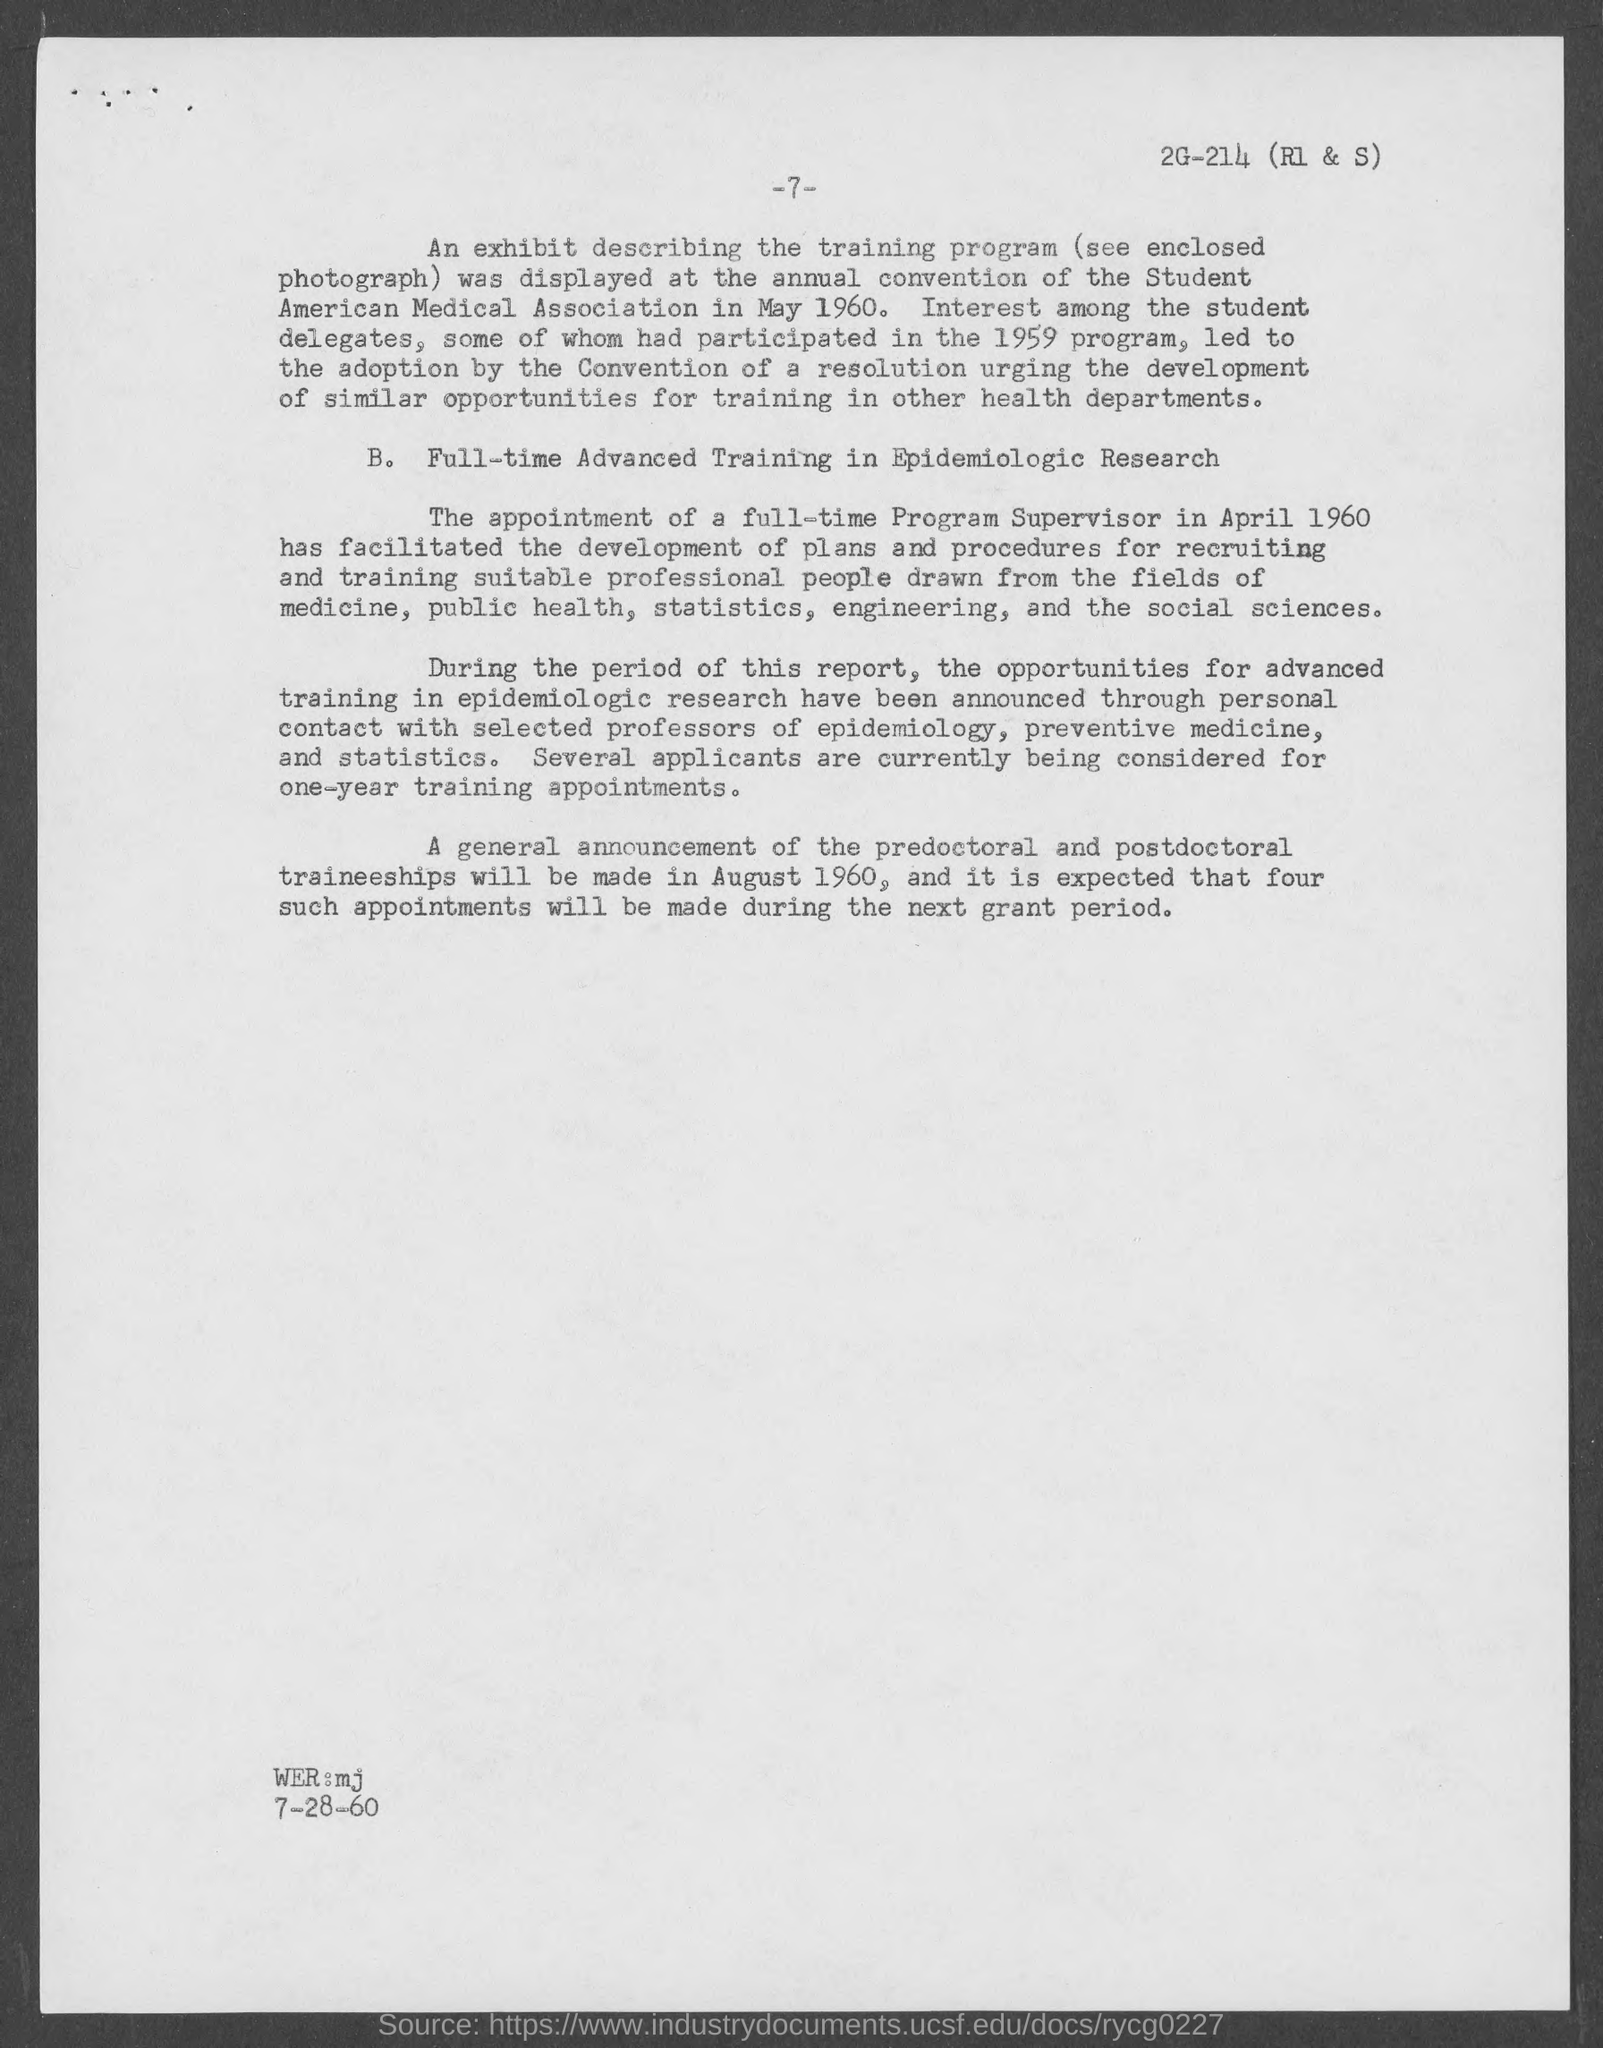Outline some significant characteristics in this image. The appointment of a full-time program supervisor was done in April 1960. It is anticipated that a general announcement regarding the predoctoral and postdoctoral traineeship will be made in August 1960. 